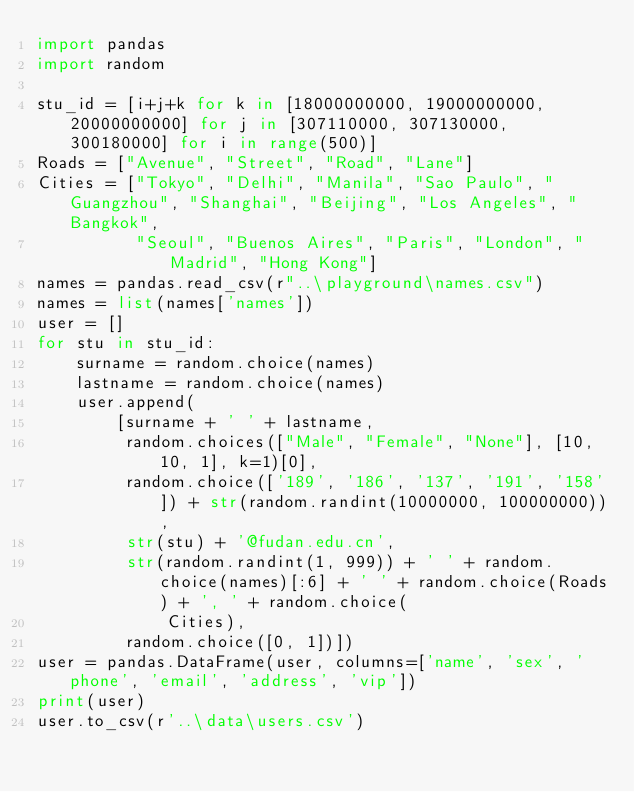<code> <loc_0><loc_0><loc_500><loc_500><_Python_>import pandas
import random

stu_id = [i+j+k for k in [18000000000, 19000000000, 20000000000] for j in [307110000, 307130000, 300180000] for i in range(500)]
Roads = ["Avenue", "Street", "Road", "Lane"]
Cities = ["Tokyo", "Delhi", "Manila", "Sao Paulo", "Guangzhou", "Shanghai", "Beijing", "Los Angeles", "Bangkok",
          "Seoul", "Buenos Aires", "Paris", "London", "Madrid", "Hong Kong"]
names = pandas.read_csv(r"..\playground\names.csv")
names = list(names['names'])
user = []
for stu in stu_id:
    surname = random.choice(names)
    lastname = random.choice(names)
    user.append(
        [surname + ' ' + lastname,
         random.choices(["Male", "Female", "None"], [10, 10, 1], k=1)[0],
         random.choice(['189', '186', '137', '191', '158']) + str(random.randint(10000000, 100000000)),
         str(stu) + '@fudan.edu.cn',
         str(random.randint(1, 999)) + ' ' + random.choice(names)[:6] + ' ' + random.choice(Roads) + ', ' + random.choice(
             Cities),
         random.choice([0, 1])])
user = pandas.DataFrame(user, columns=['name', 'sex', 'phone', 'email', 'address', 'vip'])
print(user)
user.to_csv(r'..\data\users.csv')
</code> 